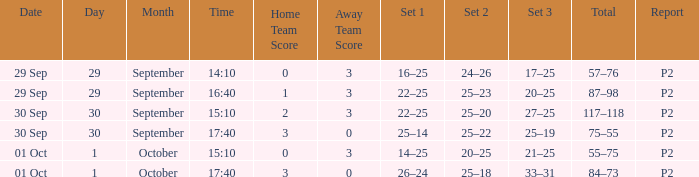What Score has a time of 14:10? 0–3. 